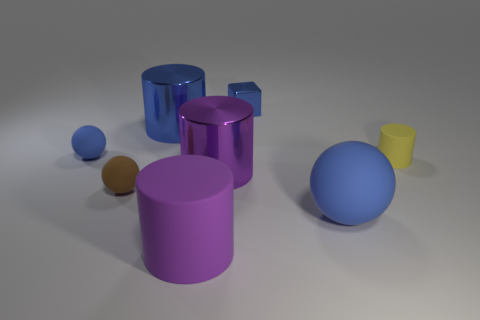What is the texture of the surface on which the objects are placed? The surface appears to be smooth with a matte finish, offering a subtle diffusion of light and soft shadows around the bases of the objects. 